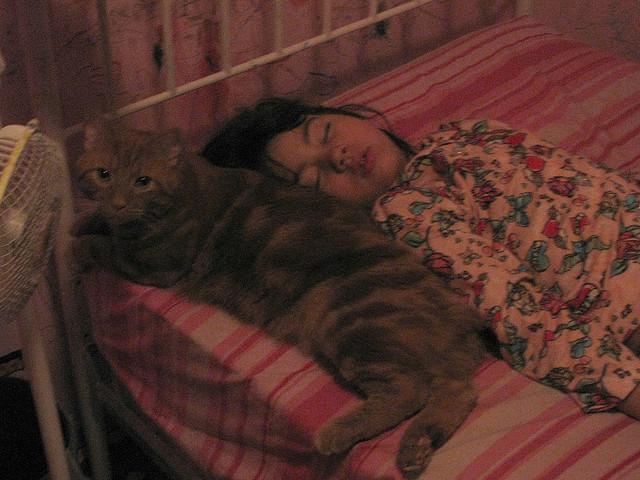How many cats are there?
Give a very brief answer. 1. How many dogs are on the street?
Give a very brief answer. 0. 